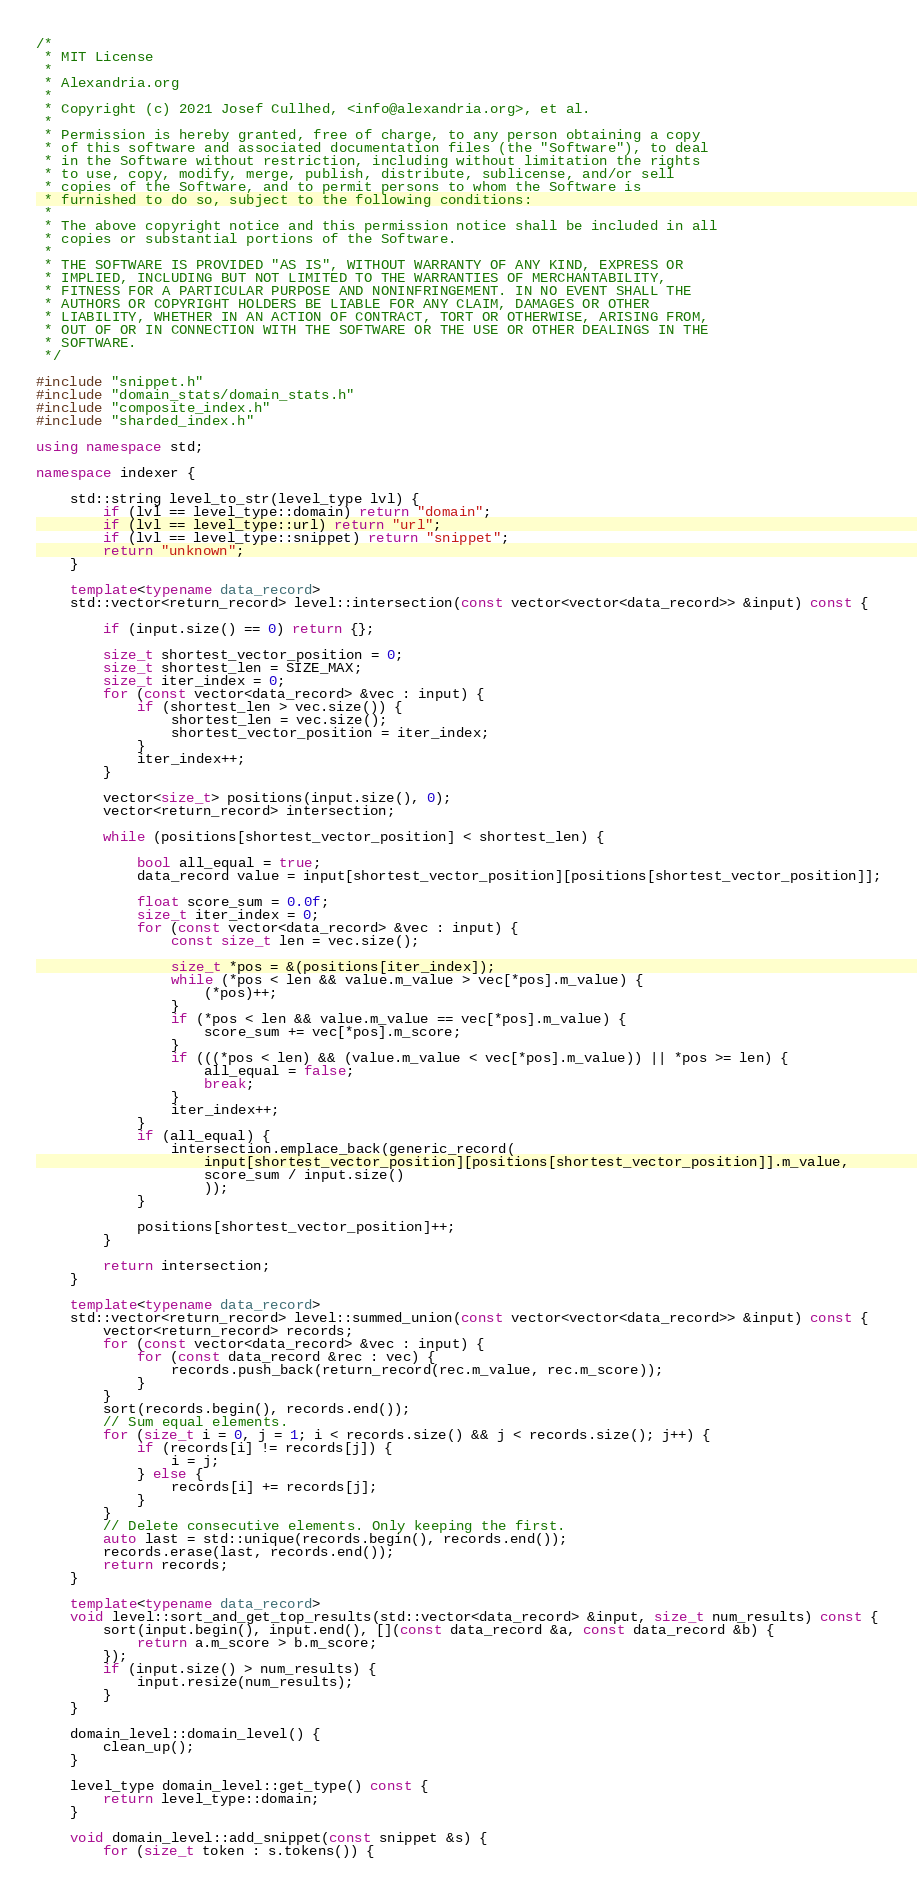<code> <loc_0><loc_0><loc_500><loc_500><_C++_>/*
 * MIT License
 *
 * Alexandria.org
 *
 * Copyright (c) 2021 Josef Cullhed, <info@alexandria.org>, et al.
 *
 * Permission is hereby granted, free of charge, to any person obtaining a copy
 * of this software and associated documentation files (the "Software"), to deal
 * in the Software without restriction, including without limitation the rights
 * to use, copy, modify, merge, publish, distribute, sublicense, and/or sell
 * copies of the Software, and to permit persons to whom the Software is
 * furnished to do so, subject to the following conditions:
 *
 * The above copyright notice and this permission notice shall be included in all
 * copies or substantial portions of the Software.
 *
 * THE SOFTWARE IS PROVIDED "AS IS", WITHOUT WARRANTY OF ANY KIND, EXPRESS OR
 * IMPLIED, INCLUDING BUT NOT LIMITED TO THE WARRANTIES OF MERCHANTABILITY,
 * FITNESS FOR A PARTICULAR PURPOSE AND NONINFRINGEMENT. IN NO EVENT SHALL THE
 * AUTHORS OR COPYRIGHT HOLDERS BE LIABLE FOR ANY CLAIM, DAMAGES OR OTHER
 * LIABILITY, WHETHER IN AN ACTION OF CONTRACT, TORT OR OTHERWISE, ARISING FROM,
 * OUT OF OR IN CONNECTION WITH THE SOFTWARE OR THE USE OR OTHER DEALINGS IN THE
 * SOFTWARE.
 */

#include "snippet.h"
#include "domain_stats/domain_stats.h"
#include "composite_index.h"
#include "sharded_index.h"

using namespace std;

namespace indexer {

	std::string level_to_str(level_type lvl) {
		if (lvl == level_type::domain) return "domain";
		if (lvl == level_type::url) return "url";
		if (lvl == level_type::snippet) return "snippet";
		return "unknown";
	}

	template<typename data_record>
	std::vector<return_record> level::intersection(const vector<vector<data_record>> &input) const {

		if (input.size() == 0) return {};

		size_t shortest_vector_position = 0;
		size_t shortest_len = SIZE_MAX;
		size_t iter_index = 0;
		for (const vector<data_record> &vec : input) {
			if (shortest_len > vec.size()) {
				shortest_len = vec.size();
				shortest_vector_position = iter_index;
			}
			iter_index++;
		}

		vector<size_t> positions(input.size(), 0);
		vector<return_record> intersection;

		while (positions[shortest_vector_position] < shortest_len) {

			bool all_equal = true;
			data_record value = input[shortest_vector_position][positions[shortest_vector_position]];

			float score_sum = 0.0f;
			size_t iter_index = 0;
			for (const vector<data_record> &vec : input) {
				const size_t len = vec.size();

				size_t *pos = &(positions[iter_index]);
				while (*pos < len && value.m_value > vec[*pos].m_value) {
					(*pos)++;
				}
				if (*pos < len && value.m_value == vec[*pos].m_value) {
					score_sum += vec[*pos].m_score;
				}
				if (((*pos < len) && (value.m_value < vec[*pos].m_value)) || *pos >= len) {
					all_equal = false;
					break;
				}
				iter_index++;
			}
			if (all_equal) {
				intersection.emplace_back(generic_record(
					input[shortest_vector_position][positions[shortest_vector_position]].m_value,
					score_sum / input.size()
					));
			}

			positions[shortest_vector_position]++;
		}

		return intersection;
	}

	template<typename data_record>
	std::vector<return_record> level::summed_union(const vector<vector<data_record>> &input) const {
		vector<return_record> records;
		for (const vector<data_record> &vec : input) {
			for (const data_record &rec : vec) {
				records.push_back(return_record(rec.m_value, rec.m_score));
			}
		}
		sort(records.begin(), records.end());
		// Sum equal elements.
		for (size_t i = 0, j = 1; i < records.size() && j < records.size(); j++) {
			if (records[i] != records[j]) {
				i = j;
			} else {
				records[i] += records[j];
			}
		}
		// Delete consecutive elements. Only keeping the first.
		auto last = std::unique(records.begin(), records.end());
		records.erase(last, records.end());
		return records;		
	}

	template<typename data_record>
	void level::sort_and_get_top_results(std::vector<data_record> &input, size_t num_results) const {
		sort(input.begin(), input.end(), [](const data_record &a, const data_record &b) {
			return a.m_score > b.m_score;
		});
		if (input.size() > num_results) {
			input.resize(num_results);
		}
	}

	domain_level::domain_level() {
		clean_up();
	}

	level_type domain_level::get_type() const {
		return level_type::domain;
	}

	void domain_level::add_snippet(const snippet &s) {
		for (size_t token : s.tokens()) {</code> 